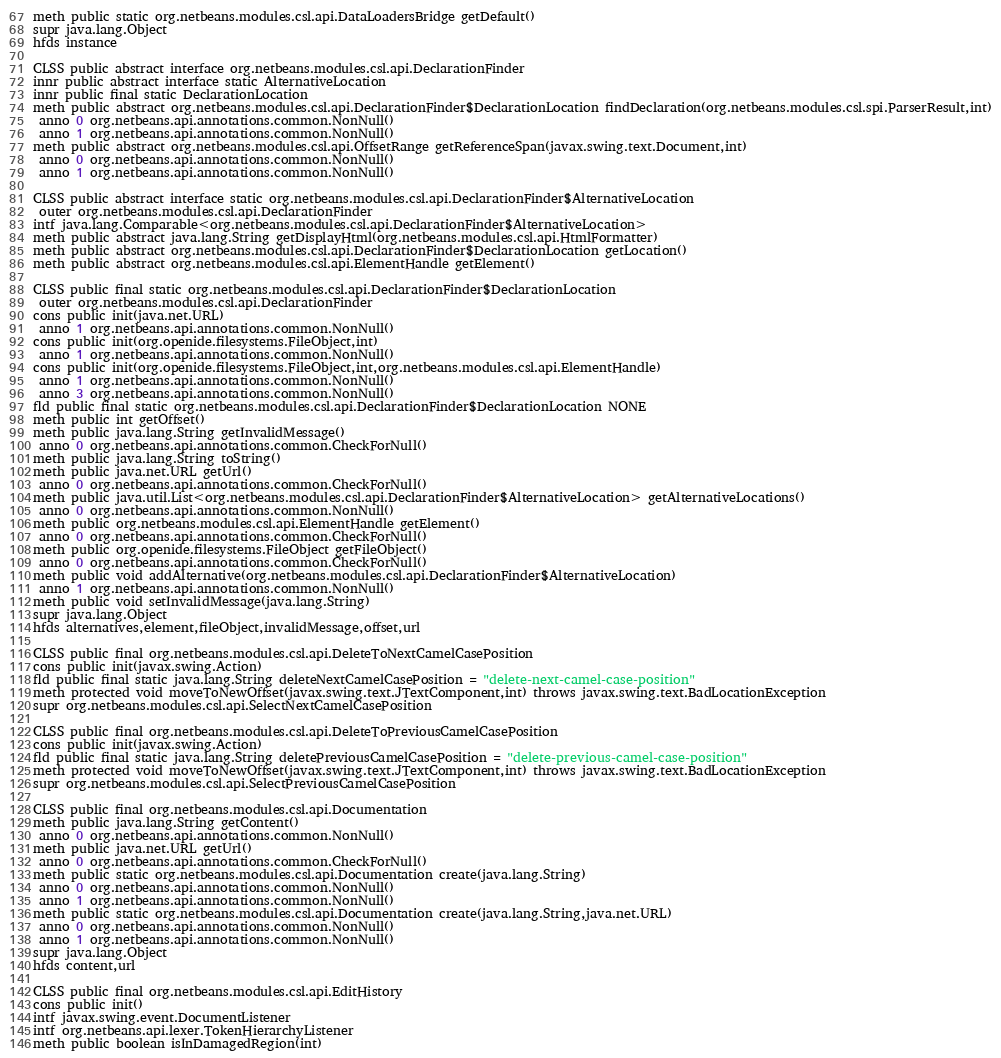Convert code to text. <code><loc_0><loc_0><loc_500><loc_500><_SML_>meth public static org.netbeans.modules.csl.api.DataLoadersBridge getDefault()
supr java.lang.Object
hfds instance

CLSS public abstract interface org.netbeans.modules.csl.api.DeclarationFinder
innr public abstract interface static AlternativeLocation
innr public final static DeclarationLocation
meth public abstract org.netbeans.modules.csl.api.DeclarationFinder$DeclarationLocation findDeclaration(org.netbeans.modules.csl.spi.ParserResult,int)
 anno 0 org.netbeans.api.annotations.common.NonNull()
 anno 1 org.netbeans.api.annotations.common.NonNull()
meth public abstract org.netbeans.modules.csl.api.OffsetRange getReferenceSpan(javax.swing.text.Document,int)
 anno 0 org.netbeans.api.annotations.common.NonNull()
 anno 1 org.netbeans.api.annotations.common.NonNull()

CLSS public abstract interface static org.netbeans.modules.csl.api.DeclarationFinder$AlternativeLocation
 outer org.netbeans.modules.csl.api.DeclarationFinder
intf java.lang.Comparable<org.netbeans.modules.csl.api.DeclarationFinder$AlternativeLocation>
meth public abstract java.lang.String getDisplayHtml(org.netbeans.modules.csl.api.HtmlFormatter)
meth public abstract org.netbeans.modules.csl.api.DeclarationFinder$DeclarationLocation getLocation()
meth public abstract org.netbeans.modules.csl.api.ElementHandle getElement()

CLSS public final static org.netbeans.modules.csl.api.DeclarationFinder$DeclarationLocation
 outer org.netbeans.modules.csl.api.DeclarationFinder
cons public init(java.net.URL)
 anno 1 org.netbeans.api.annotations.common.NonNull()
cons public init(org.openide.filesystems.FileObject,int)
 anno 1 org.netbeans.api.annotations.common.NonNull()
cons public init(org.openide.filesystems.FileObject,int,org.netbeans.modules.csl.api.ElementHandle)
 anno 1 org.netbeans.api.annotations.common.NonNull()
 anno 3 org.netbeans.api.annotations.common.NonNull()
fld public final static org.netbeans.modules.csl.api.DeclarationFinder$DeclarationLocation NONE
meth public int getOffset()
meth public java.lang.String getInvalidMessage()
 anno 0 org.netbeans.api.annotations.common.CheckForNull()
meth public java.lang.String toString()
meth public java.net.URL getUrl()
 anno 0 org.netbeans.api.annotations.common.CheckForNull()
meth public java.util.List<org.netbeans.modules.csl.api.DeclarationFinder$AlternativeLocation> getAlternativeLocations()
 anno 0 org.netbeans.api.annotations.common.NonNull()
meth public org.netbeans.modules.csl.api.ElementHandle getElement()
 anno 0 org.netbeans.api.annotations.common.CheckForNull()
meth public org.openide.filesystems.FileObject getFileObject()
 anno 0 org.netbeans.api.annotations.common.CheckForNull()
meth public void addAlternative(org.netbeans.modules.csl.api.DeclarationFinder$AlternativeLocation)
 anno 1 org.netbeans.api.annotations.common.NonNull()
meth public void setInvalidMessage(java.lang.String)
supr java.lang.Object
hfds alternatives,element,fileObject,invalidMessage,offset,url

CLSS public final org.netbeans.modules.csl.api.DeleteToNextCamelCasePosition
cons public init(javax.swing.Action)
fld public final static java.lang.String deleteNextCamelCasePosition = "delete-next-camel-case-position"
meth protected void moveToNewOffset(javax.swing.text.JTextComponent,int) throws javax.swing.text.BadLocationException
supr org.netbeans.modules.csl.api.SelectNextCamelCasePosition

CLSS public final org.netbeans.modules.csl.api.DeleteToPreviousCamelCasePosition
cons public init(javax.swing.Action)
fld public final static java.lang.String deletePreviousCamelCasePosition = "delete-previous-camel-case-position"
meth protected void moveToNewOffset(javax.swing.text.JTextComponent,int) throws javax.swing.text.BadLocationException
supr org.netbeans.modules.csl.api.SelectPreviousCamelCasePosition

CLSS public final org.netbeans.modules.csl.api.Documentation
meth public java.lang.String getContent()
 anno 0 org.netbeans.api.annotations.common.NonNull()
meth public java.net.URL getUrl()
 anno 0 org.netbeans.api.annotations.common.CheckForNull()
meth public static org.netbeans.modules.csl.api.Documentation create(java.lang.String)
 anno 0 org.netbeans.api.annotations.common.NonNull()
 anno 1 org.netbeans.api.annotations.common.NonNull()
meth public static org.netbeans.modules.csl.api.Documentation create(java.lang.String,java.net.URL)
 anno 0 org.netbeans.api.annotations.common.NonNull()
 anno 1 org.netbeans.api.annotations.common.NonNull()
supr java.lang.Object
hfds content,url

CLSS public final org.netbeans.modules.csl.api.EditHistory
cons public init()
intf javax.swing.event.DocumentListener
intf org.netbeans.api.lexer.TokenHierarchyListener
meth public boolean isInDamagedRegion(int)</code> 